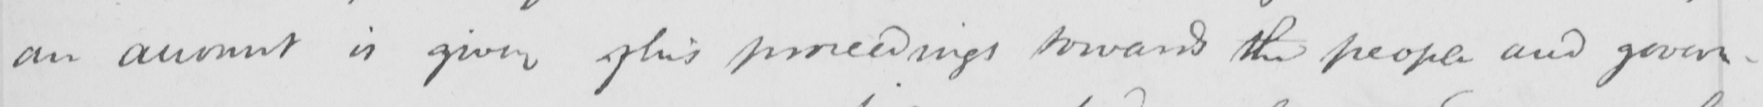What is written in this line of handwriting? an account is given of his proceedings toward the people and govern- 